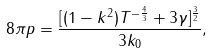Convert formula to latex. <formula><loc_0><loc_0><loc_500><loc_500>8 \pi p = \frac { [ ( 1 - k ^ { 2 } ) T ^ { - \frac { 4 } { 3 } } + 3 \gamma ] ^ { \frac { 3 } { 2 } } } { 3 k _ { 0 } } ,</formula> 